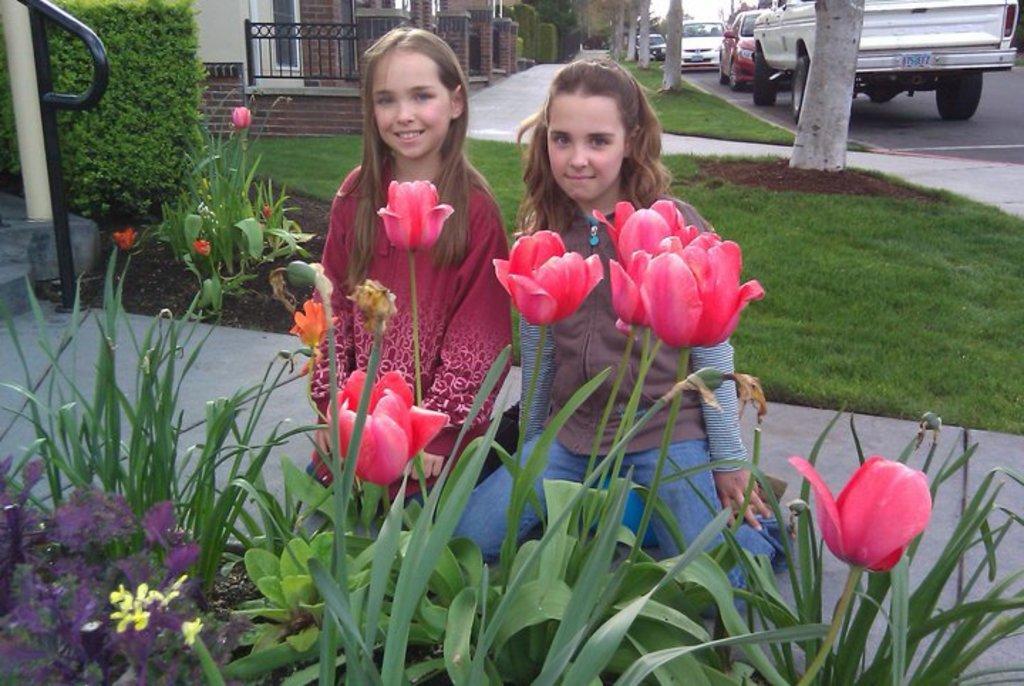How would you summarize this image in a sentence or two? In the picture we can see some grass plants with flowers and behind it, we can see two girls are sitting on the knee and in the background we can see a some houses with railing and vehicles near the road. 